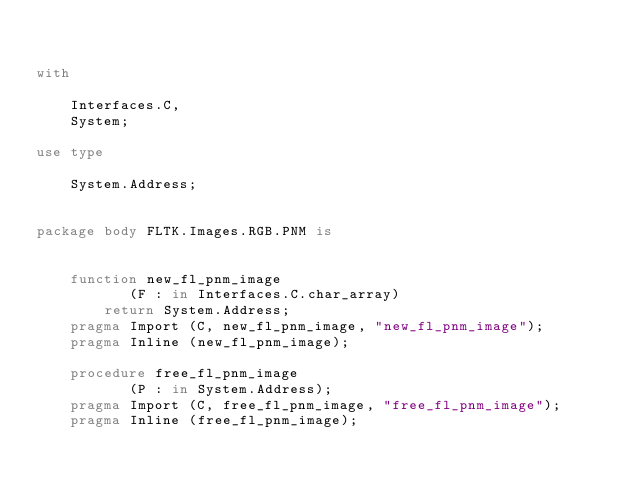Convert code to text. <code><loc_0><loc_0><loc_500><loc_500><_Ada_>

with

    Interfaces.C,
    System;

use type

    System.Address;


package body FLTK.Images.RGB.PNM is


    function new_fl_pnm_image
           (F : in Interfaces.C.char_array)
        return System.Address;
    pragma Import (C, new_fl_pnm_image, "new_fl_pnm_image");
    pragma Inline (new_fl_pnm_image);

    procedure free_fl_pnm_image
           (P : in System.Address);
    pragma Import (C, free_fl_pnm_image, "free_fl_pnm_image");
    pragma Inline (free_fl_pnm_image);



</code> 